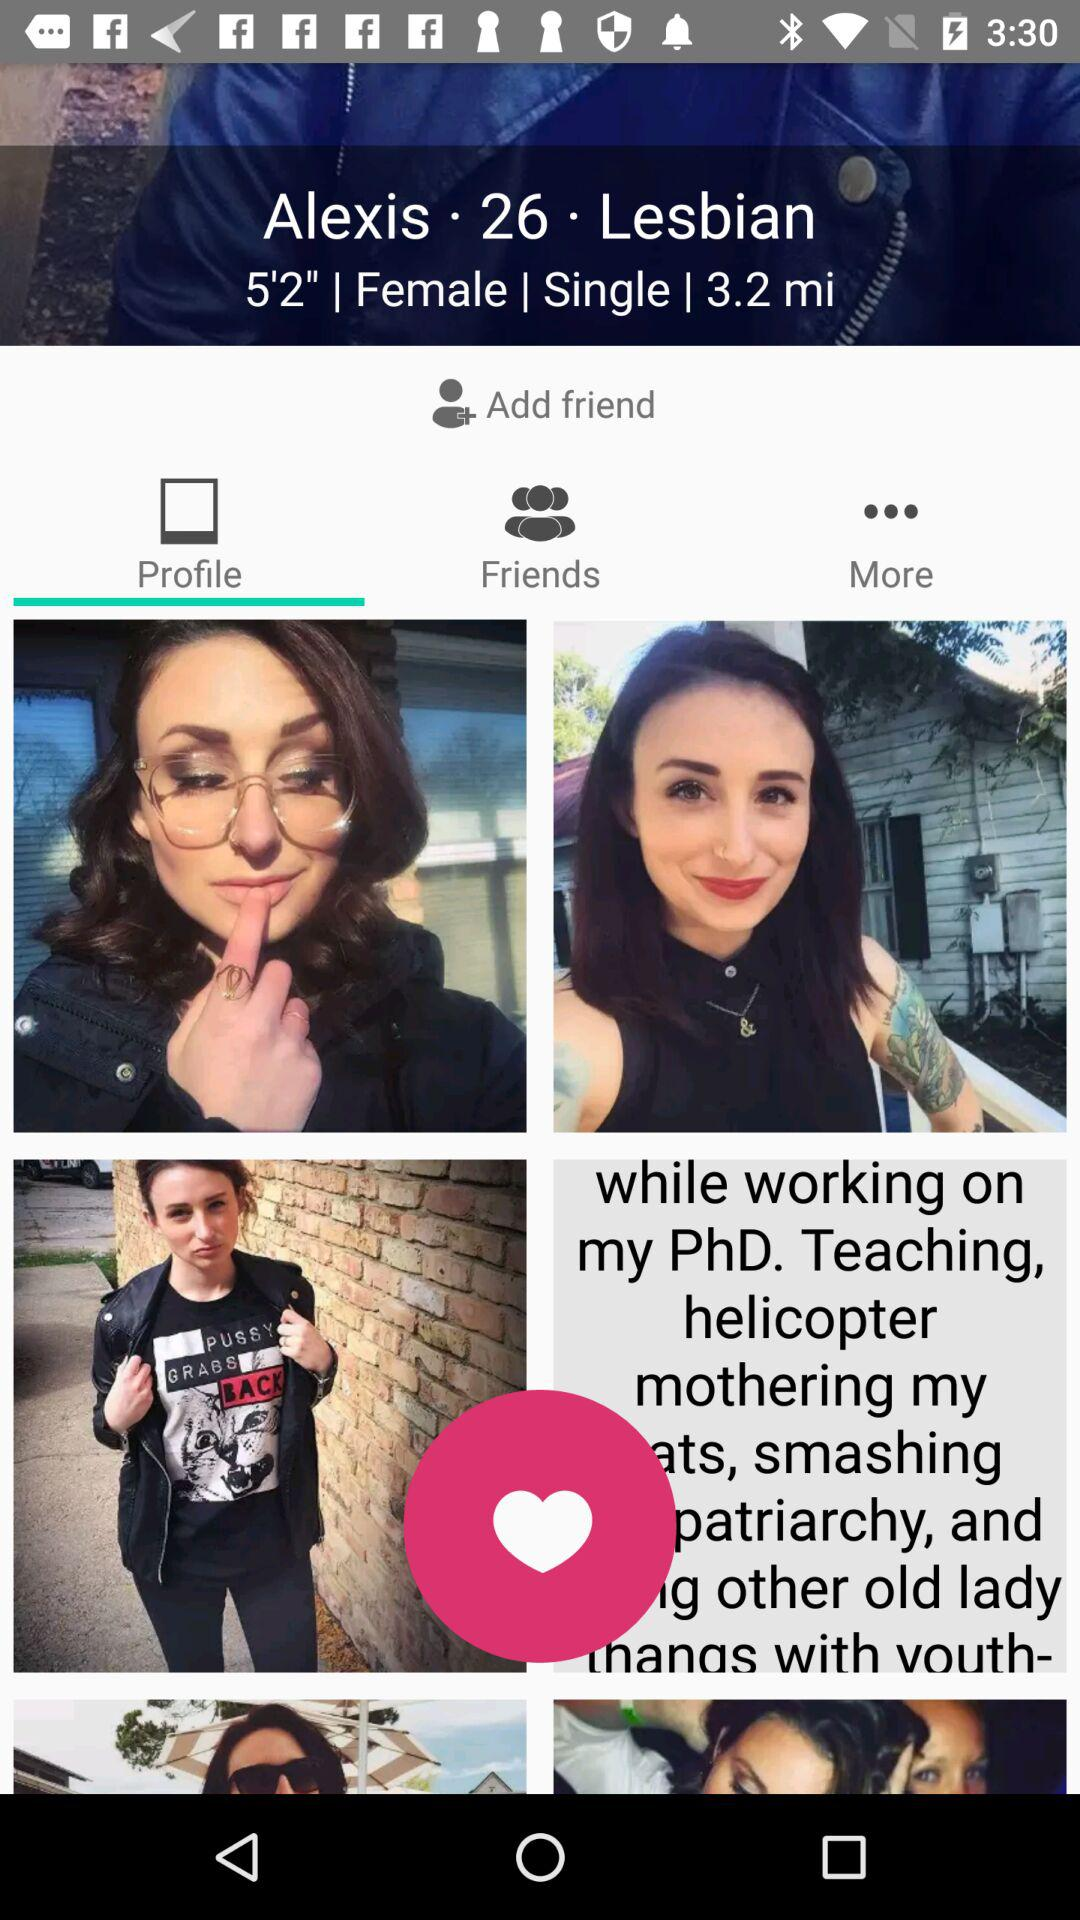How many friends does Alexis have?
When the provided information is insufficient, respond with <no answer>. <no answer> 